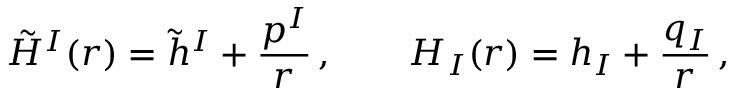Convert formula to latex. <formula><loc_0><loc_0><loc_500><loc_500>\tilde { H } ^ { I } ( r ) = \tilde { h } ^ { I } + { \frac { p ^ { I } } { r } } \, , \quad H _ { I } ( r ) = h _ { I } + { \frac { q _ { I } } { r } } \, ,</formula> 